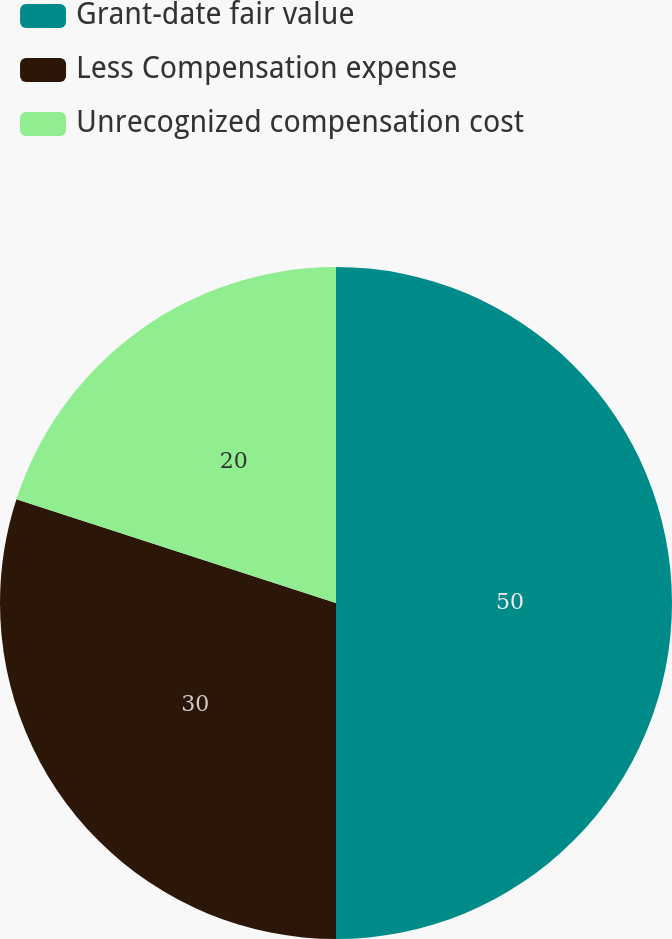<chart> <loc_0><loc_0><loc_500><loc_500><pie_chart><fcel>Grant-date fair value<fcel>Less Compensation expense<fcel>Unrecognized compensation cost<nl><fcel>50.0%<fcel>30.0%<fcel>20.0%<nl></chart> 